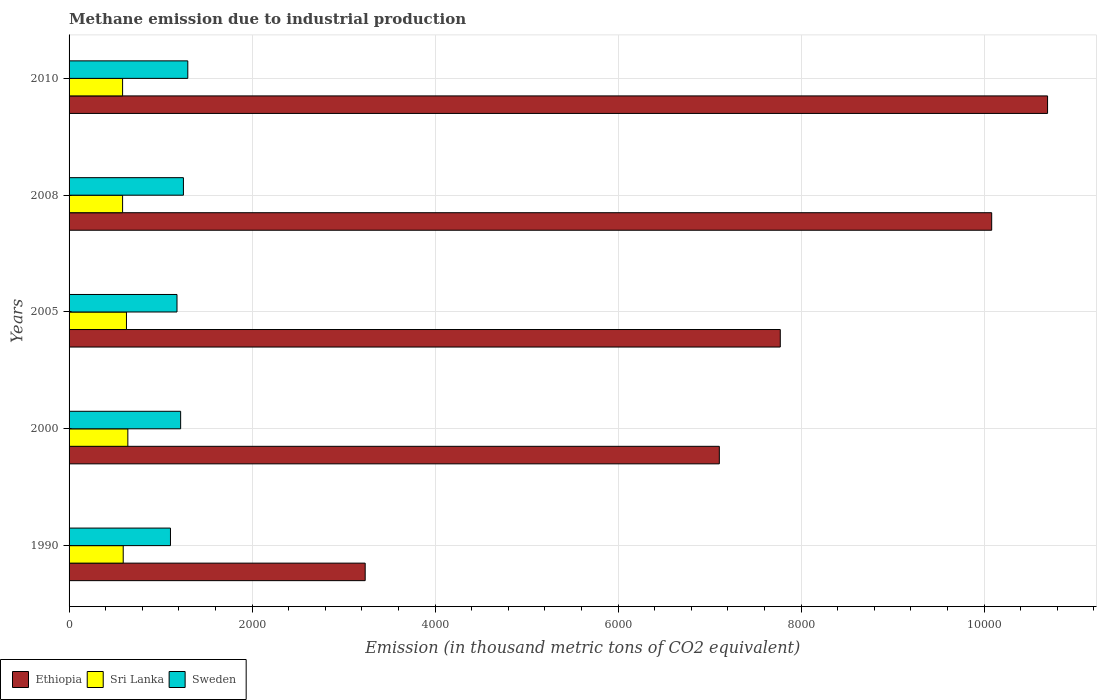How many groups of bars are there?
Offer a terse response. 5. In how many cases, is the number of bars for a given year not equal to the number of legend labels?
Keep it short and to the point. 0. What is the amount of methane emitted in Sri Lanka in 2008?
Offer a terse response. 584.9. Across all years, what is the maximum amount of methane emitted in Ethiopia?
Make the answer very short. 1.07e+04. Across all years, what is the minimum amount of methane emitted in Ethiopia?
Ensure brevity in your answer.  3236. In which year was the amount of methane emitted in Ethiopia minimum?
Provide a short and direct response. 1990. What is the total amount of methane emitted in Sweden in the graph?
Provide a succinct answer. 6054. What is the difference between the amount of methane emitted in Ethiopia in 1990 and that in 2000?
Your answer should be very brief. -3870. What is the difference between the amount of methane emitted in Sweden in 1990 and the amount of methane emitted in Ethiopia in 2008?
Make the answer very short. -8974.2. What is the average amount of methane emitted in Ethiopia per year?
Offer a terse response. 7777.88. In the year 2000, what is the difference between the amount of methane emitted in Ethiopia and amount of methane emitted in Sri Lanka?
Your response must be concise. 6463.8. What is the ratio of the amount of methane emitted in Sri Lanka in 2000 to that in 2005?
Your answer should be very brief. 1.02. Is the amount of methane emitted in Sweden in 2000 less than that in 2005?
Provide a short and direct response. No. Is the difference between the amount of methane emitted in Ethiopia in 2000 and 2010 greater than the difference between the amount of methane emitted in Sri Lanka in 2000 and 2010?
Give a very brief answer. No. What is the difference between the highest and the second highest amount of methane emitted in Sri Lanka?
Your response must be concise. 14.9. What is the difference between the highest and the lowest amount of methane emitted in Sweden?
Your answer should be compact. 189.4. In how many years, is the amount of methane emitted in Ethiopia greater than the average amount of methane emitted in Ethiopia taken over all years?
Provide a succinct answer. 2. Is the sum of the amount of methane emitted in Sweden in 2008 and 2010 greater than the maximum amount of methane emitted in Ethiopia across all years?
Give a very brief answer. No. What does the 3rd bar from the top in 2005 represents?
Offer a very short reply. Ethiopia. What does the 2nd bar from the bottom in 2008 represents?
Provide a short and direct response. Sri Lanka. Is it the case that in every year, the sum of the amount of methane emitted in Sri Lanka and amount of methane emitted in Ethiopia is greater than the amount of methane emitted in Sweden?
Make the answer very short. Yes. How many bars are there?
Your answer should be compact. 15. How many years are there in the graph?
Make the answer very short. 5. What is the difference between two consecutive major ticks on the X-axis?
Your answer should be very brief. 2000. Does the graph contain any zero values?
Provide a succinct answer. No. Does the graph contain grids?
Offer a terse response. Yes. Where does the legend appear in the graph?
Your answer should be very brief. Bottom left. What is the title of the graph?
Offer a terse response. Methane emission due to industrial production. Does "Burundi" appear as one of the legend labels in the graph?
Your answer should be compact. No. What is the label or title of the X-axis?
Your answer should be compact. Emission (in thousand metric tons of CO2 equivalent). What is the label or title of the Y-axis?
Your answer should be very brief. Years. What is the Emission (in thousand metric tons of CO2 equivalent) of Ethiopia in 1990?
Provide a succinct answer. 3236. What is the Emission (in thousand metric tons of CO2 equivalent) in Sri Lanka in 1990?
Make the answer very short. 591.8. What is the Emission (in thousand metric tons of CO2 equivalent) of Sweden in 1990?
Give a very brief answer. 1108.1. What is the Emission (in thousand metric tons of CO2 equivalent) in Ethiopia in 2000?
Your answer should be compact. 7106. What is the Emission (in thousand metric tons of CO2 equivalent) in Sri Lanka in 2000?
Your answer should be very brief. 642.2. What is the Emission (in thousand metric tons of CO2 equivalent) in Sweden in 2000?
Ensure brevity in your answer.  1219.3. What is the Emission (in thousand metric tons of CO2 equivalent) of Ethiopia in 2005?
Ensure brevity in your answer.  7772.1. What is the Emission (in thousand metric tons of CO2 equivalent) in Sri Lanka in 2005?
Provide a short and direct response. 627.3. What is the Emission (in thousand metric tons of CO2 equivalent) in Sweden in 2005?
Keep it short and to the point. 1179.4. What is the Emission (in thousand metric tons of CO2 equivalent) of Ethiopia in 2008?
Give a very brief answer. 1.01e+04. What is the Emission (in thousand metric tons of CO2 equivalent) in Sri Lanka in 2008?
Offer a terse response. 584.9. What is the Emission (in thousand metric tons of CO2 equivalent) in Sweden in 2008?
Offer a very short reply. 1249.7. What is the Emission (in thousand metric tons of CO2 equivalent) in Ethiopia in 2010?
Ensure brevity in your answer.  1.07e+04. What is the Emission (in thousand metric tons of CO2 equivalent) of Sri Lanka in 2010?
Your answer should be compact. 584.9. What is the Emission (in thousand metric tons of CO2 equivalent) in Sweden in 2010?
Provide a short and direct response. 1297.5. Across all years, what is the maximum Emission (in thousand metric tons of CO2 equivalent) of Ethiopia?
Keep it short and to the point. 1.07e+04. Across all years, what is the maximum Emission (in thousand metric tons of CO2 equivalent) in Sri Lanka?
Your response must be concise. 642.2. Across all years, what is the maximum Emission (in thousand metric tons of CO2 equivalent) in Sweden?
Make the answer very short. 1297.5. Across all years, what is the minimum Emission (in thousand metric tons of CO2 equivalent) in Ethiopia?
Your response must be concise. 3236. Across all years, what is the minimum Emission (in thousand metric tons of CO2 equivalent) of Sri Lanka?
Your answer should be compact. 584.9. Across all years, what is the minimum Emission (in thousand metric tons of CO2 equivalent) in Sweden?
Offer a terse response. 1108.1. What is the total Emission (in thousand metric tons of CO2 equivalent) of Ethiopia in the graph?
Your answer should be compact. 3.89e+04. What is the total Emission (in thousand metric tons of CO2 equivalent) of Sri Lanka in the graph?
Your response must be concise. 3031.1. What is the total Emission (in thousand metric tons of CO2 equivalent) in Sweden in the graph?
Provide a succinct answer. 6054. What is the difference between the Emission (in thousand metric tons of CO2 equivalent) in Ethiopia in 1990 and that in 2000?
Give a very brief answer. -3870. What is the difference between the Emission (in thousand metric tons of CO2 equivalent) in Sri Lanka in 1990 and that in 2000?
Keep it short and to the point. -50.4. What is the difference between the Emission (in thousand metric tons of CO2 equivalent) of Sweden in 1990 and that in 2000?
Offer a very short reply. -111.2. What is the difference between the Emission (in thousand metric tons of CO2 equivalent) in Ethiopia in 1990 and that in 2005?
Your answer should be very brief. -4536.1. What is the difference between the Emission (in thousand metric tons of CO2 equivalent) in Sri Lanka in 1990 and that in 2005?
Provide a short and direct response. -35.5. What is the difference between the Emission (in thousand metric tons of CO2 equivalent) in Sweden in 1990 and that in 2005?
Offer a terse response. -71.3. What is the difference between the Emission (in thousand metric tons of CO2 equivalent) in Ethiopia in 1990 and that in 2008?
Your answer should be very brief. -6846.3. What is the difference between the Emission (in thousand metric tons of CO2 equivalent) of Sweden in 1990 and that in 2008?
Your answer should be compact. -141.6. What is the difference between the Emission (in thousand metric tons of CO2 equivalent) of Ethiopia in 1990 and that in 2010?
Make the answer very short. -7457. What is the difference between the Emission (in thousand metric tons of CO2 equivalent) of Sri Lanka in 1990 and that in 2010?
Your response must be concise. 6.9. What is the difference between the Emission (in thousand metric tons of CO2 equivalent) of Sweden in 1990 and that in 2010?
Provide a short and direct response. -189.4. What is the difference between the Emission (in thousand metric tons of CO2 equivalent) of Ethiopia in 2000 and that in 2005?
Provide a short and direct response. -666.1. What is the difference between the Emission (in thousand metric tons of CO2 equivalent) in Sweden in 2000 and that in 2005?
Offer a very short reply. 39.9. What is the difference between the Emission (in thousand metric tons of CO2 equivalent) in Ethiopia in 2000 and that in 2008?
Offer a terse response. -2976.3. What is the difference between the Emission (in thousand metric tons of CO2 equivalent) of Sri Lanka in 2000 and that in 2008?
Offer a very short reply. 57.3. What is the difference between the Emission (in thousand metric tons of CO2 equivalent) in Sweden in 2000 and that in 2008?
Give a very brief answer. -30.4. What is the difference between the Emission (in thousand metric tons of CO2 equivalent) in Ethiopia in 2000 and that in 2010?
Provide a short and direct response. -3587. What is the difference between the Emission (in thousand metric tons of CO2 equivalent) of Sri Lanka in 2000 and that in 2010?
Offer a very short reply. 57.3. What is the difference between the Emission (in thousand metric tons of CO2 equivalent) of Sweden in 2000 and that in 2010?
Your answer should be compact. -78.2. What is the difference between the Emission (in thousand metric tons of CO2 equivalent) in Ethiopia in 2005 and that in 2008?
Keep it short and to the point. -2310.2. What is the difference between the Emission (in thousand metric tons of CO2 equivalent) of Sri Lanka in 2005 and that in 2008?
Ensure brevity in your answer.  42.4. What is the difference between the Emission (in thousand metric tons of CO2 equivalent) of Sweden in 2005 and that in 2008?
Make the answer very short. -70.3. What is the difference between the Emission (in thousand metric tons of CO2 equivalent) of Ethiopia in 2005 and that in 2010?
Provide a succinct answer. -2920.9. What is the difference between the Emission (in thousand metric tons of CO2 equivalent) of Sri Lanka in 2005 and that in 2010?
Your answer should be very brief. 42.4. What is the difference between the Emission (in thousand metric tons of CO2 equivalent) in Sweden in 2005 and that in 2010?
Provide a succinct answer. -118.1. What is the difference between the Emission (in thousand metric tons of CO2 equivalent) of Ethiopia in 2008 and that in 2010?
Make the answer very short. -610.7. What is the difference between the Emission (in thousand metric tons of CO2 equivalent) of Sri Lanka in 2008 and that in 2010?
Offer a terse response. 0. What is the difference between the Emission (in thousand metric tons of CO2 equivalent) in Sweden in 2008 and that in 2010?
Make the answer very short. -47.8. What is the difference between the Emission (in thousand metric tons of CO2 equivalent) of Ethiopia in 1990 and the Emission (in thousand metric tons of CO2 equivalent) of Sri Lanka in 2000?
Make the answer very short. 2593.8. What is the difference between the Emission (in thousand metric tons of CO2 equivalent) in Ethiopia in 1990 and the Emission (in thousand metric tons of CO2 equivalent) in Sweden in 2000?
Your response must be concise. 2016.7. What is the difference between the Emission (in thousand metric tons of CO2 equivalent) in Sri Lanka in 1990 and the Emission (in thousand metric tons of CO2 equivalent) in Sweden in 2000?
Your answer should be very brief. -627.5. What is the difference between the Emission (in thousand metric tons of CO2 equivalent) of Ethiopia in 1990 and the Emission (in thousand metric tons of CO2 equivalent) of Sri Lanka in 2005?
Provide a succinct answer. 2608.7. What is the difference between the Emission (in thousand metric tons of CO2 equivalent) of Ethiopia in 1990 and the Emission (in thousand metric tons of CO2 equivalent) of Sweden in 2005?
Give a very brief answer. 2056.6. What is the difference between the Emission (in thousand metric tons of CO2 equivalent) of Sri Lanka in 1990 and the Emission (in thousand metric tons of CO2 equivalent) of Sweden in 2005?
Provide a short and direct response. -587.6. What is the difference between the Emission (in thousand metric tons of CO2 equivalent) of Ethiopia in 1990 and the Emission (in thousand metric tons of CO2 equivalent) of Sri Lanka in 2008?
Your answer should be very brief. 2651.1. What is the difference between the Emission (in thousand metric tons of CO2 equivalent) in Ethiopia in 1990 and the Emission (in thousand metric tons of CO2 equivalent) in Sweden in 2008?
Provide a succinct answer. 1986.3. What is the difference between the Emission (in thousand metric tons of CO2 equivalent) of Sri Lanka in 1990 and the Emission (in thousand metric tons of CO2 equivalent) of Sweden in 2008?
Your response must be concise. -657.9. What is the difference between the Emission (in thousand metric tons of CO2 equivalent) of Ethiopia in 1990 and the Emission (in thousand metric tons of CO2 equivalent) of Sri Lanka in 2010?
Make the answer very short. 2651.1. What is the difference between the Emission (in thousand metric tons of CO2 equivalent) of Ethiopia in 1990 and the Emission (in thousand metric tons of CO2 equivalent) of Sweden in 2010?
Provide a succinct answer. 1938.5. What is the difference between the Emission (in thousand metric tons of CO2 equivalent) of Sri Lanka in 1990 and the Emission (in thousand metric tons of CO2 equivalent) of Sweden in 2010?
Give a very brief answer. -705.7. What is the difference between the Emission (in thousand metric tons of CO2 equivalent) of Ethiopia in 2000 and the Emission (in thousand metric tons of CO2 equivalent) of Sri Lanka in 2005?
Your answer should be very brief. 6478.7. What is the difference between the Emission (in thousand metric tons of CO2 equivalent) in Ethiopia in 2000 and the Emission (in thousand metric tons of CO2 equivalent) in Sweden in 2005?
Keep it short and to the point. 5926.6. What is the difference between the Emission (in thousand metric tons of CO2 equivalent) of Sri Lanka in 2000 and the Emission (in thousand metric tons of CO2 equivalent) of Sweden in 2005?
Ensure brevity in your answer.  -537.2. What is the difference between the Emission (in thousand metric tons of CO2 equivalent) of Ethiopia in 2000 and the Emission (in thousand metric tons of CO2 equivalent) of Sri Lanka in 2008?
Give a very brief answer. 6521.1. What is the difference between the Emission (in thousand metric tons of CO2 equivalent) of Ethiopia in 2000 and the Emission (in thousand metric tons of CO2 equivalent) of Sweden in 2008?
Your response must be concise. 5856.3. What is the difference between the Emission (in thousand metric tons of CO2 equivalent) in Sri Lanka in 2000 and the Emission (in thousand metric tons of CO2 equivalent) in Sweden in 2008?
Keep it short and to the point. -607.5. What is the difference between the Emission (in thousand metric tons of CO2 equivalent) in Ethiopia in 2000 and the Emission (in thousand metric tons of CO2 equivalent) in Sri Lanka in 2010?
Keep it short and to the point. 6521.1. What is the difference between the Emission (in thousand metric tons of CO2 equivalent) in Ethiopia in 2000 and the Emission (in thousand metric tons of CO2 equivalent) in Sweden in 2010?
Keep it short and to the point. 5808.5. What is the difference between the Emission (in thousand metric tons of CO2 equivalent) of Sri Lanka in 2000 and the Emission (in thousand metric tons of CO2 equivalent) of Sweden in 2010?
Offer a very short reply. -655.3. What is the difference between the Emission (in thousand metric tons of CO2 equivalent) in Ethiopia in 2005 and the Emission (in thousand metric tons of CO2 equivalent) in Sri Lanka in 2008?
Ensure brevity in your answer.  7187.2. What is the difference between the Emission (in thousand metric tons of CO2 equivalent) of Ethiopia in 2005 and the Emission (in thousand metric tons of CO2 equivalent) of Sweden in 2008?
Your response must be concise. 6522.4. What is the difference between the Emission (in thousand metric tons of CO2 equivalent) in Sri Lanka in 2005 and the Emission (in thousand metric tons of CO2 equivalent) in Sweden in 2008?
Keep it short and to the point. -622.4. What is the difference between the Emission (in thousand metric tons of CO2 equivalent) of Ethiopia in 2005 and the Emission (in thousand metric tons of CO2 equivalent) of Sri Lanka in 2010?
Your answer should be very brief. 7187.2. What is the difference between the Emission (in thousand metric tons of CO2 equivalent) of Ethiopia in 2005 and the Emission (in thousand metric tons of CO2 equivalent) of Sweden in 2010?
Provide a short and direct response. 6474.6. What is the difference between the Emission (in thousand metric tons of CO2 equivalent) in Sri Lanka in 2005 and the Emission (in thousand metric tons of CO2 equivalent) in Sweden in 2010?
Your response must be concise. -670.2. What is the difference between the Emission (in thousand metric tons of CO2 equivalent) of Ethiopia in 2008 and the Emission (in thousand metric tons of CO2 equivalent) of Sri Lanka in 2010?
Offer a terse response. 9497.4. What is the difference between the Emission (in thousand metric tons of CO2 equivalent) of Ethiopia in 2008 and the Emission (in thousand metric tons of CO2 equivalent) of Sweden in 2010?
Your response must be concise. 8784.8. What is the difference between the Emission (in thousand metric tons of CO2 equivalent) of Sri Lanka in 2008 and the Emission (in thousand metric tons of CO2 equivalent) of Sweden in 2010?
Your answer should be very brief. -712.6. What is the average Emission (in thousand metric tons of CO2 equivalent) of Ethiopia per year?
Provide a short and direct response. 7777.88. What is the average Emission (in thousand metric tons of CO2 equivalent) in Sri Lanka per year?
Provide a succinct answer. 606.22. What is the average Emission (in thousand metric tons of CO2 equivalent) in Sweden per year?
Provide a succinct answer. 1210.8. In the year 1990, what is the difference between the Emission (in thousand metric tons of CO2 equivalent) in Ethiopia and Emission (in thousand metric tons of CO2 equivalent) in Sri Lanka?
Offer a terse response. 2644.2. In the year 1990, what is the difference between the Emission (in thousand metric tons of CO2 equivalent) in Ethiopia and Emission (in thousand metric tons of CO2 equivalent) in Sweden?
Your answer should be compact. 2127.9. In the year 1990, what is the difference between the Emission (in thousand metric tons of CO2 equivalent) in Sri Lanka and Emission (in thousand metric tons of CO2 equivalent) in Sweden?
Keep it short and to the point. -516.3. In the year 2000, what is the difference between the Emission (in thousand metric tons of CO2 equivalent) in Ethiopia and Emission (in thousand metric tons of CO2 equivalent) in Sri Lanka?
Keep it short and to the point. 6463.8. In the year 2000, what is the difference between the Emission (in thousand metric tons of CO2 equivalent) of Ethiopia and Emission (in thousand metric tons of CO2 equivalent) of Sweden?
Keep it short and to the point. 5886.7. In the year 2000, what is the difference between the Emission (in thousand metric tons of CO2 equivalent) in Sri Lanka and Emission (in thousand metric tons of CO2 equivalent) in Sweden?
Your response must be concise. -577.1. In the year 2005, what is the difference between the Emission (in thousand metric tons of CO2 equivalent) of Ethiopia and Emission (in thousand metric tons of CO2 equivalent) of Sri Lanka?
Offer a terse response. 7144.8. In the year 2005, what is the difference between the Emission (in thousand metric tons of CO2 equivalent) of Ethiopia and Emission (in thousand metric tons of CO2 equivalent) of Sweden?
Give a very brief answer. 6592.7. In the year 2005, what is the difference between the Emission (in thousand metric tons of CO2 equivalent) of Sri Lanka and Emission (in thousand metric tons of CO2 equivalent) of Sweden?
Provide a succinct answer. -552.1. In the year 2008, what is the difference between the Emission (in thousand metric tons of CO2 equivalent) of Ethiopia and Emission (in thousand metric tons of CO2 equivalent) of Sri Lanka?
Your answer should be compact. 9497.4. In the year 2008, what is the difference between the Emission (in thousand metric tons of CO2 equivalent) in Ethiopia and Emission (in thousand metric tons of CO2 equivalent) in Sweden?
Give a very brief answer. 8832.6. In the year 2008, what is the difference between the Emission (in thousand metric tons of CO2 equivalent) in Sri Lanka and Emission (in thousand metric tons of CO2 equivalent) in Sweden?
Offer a very short reply. -664.8. In the year 2010, what is the difference between the Emission (in thousand metric tons of CO2 equivalent) of Ethiopia and Emission (in thousand metric tons of CO2 equivalent) of Sri Lanka?
Offer a very short reply. 1.01e+04. In the year 2010, what is the difference between the Emission (in thousand metric tons of CO2 equivalent) in Ethiopia and Emission (in thousand metric tons of CO2 equivalent) in Sweden?
Offer a very short reply. 9395.5. In the year 2010, what is the difference between the Emission (in thousand metric tons of CO2 equivalent) of Sri Lanka and Emission (in thousand metric tons of CO2 equivalent) of Sweden?
Provide a succinct answer. -712.6. What is the ratio of the Emission (in thousand metric tons of CO2 equivalent) in Ethiopia in 1990 to that in 2000?
Ensure brevity in your answer.  0.46. What is the ratio of the Emission (in thousand metric tons of CO2 equivalent) of Sri Lanka in 1990 to that in 2000?
Keep it short and to the point. 0.92. What is the ratio of the Emission (in thousand metric tons of CO2 equivalent) of Sweden in 1990 to that in 2000?
Ensure brevity in your answer.  0.91. What is the ratio of the Emission (in thousand metric tons of CO2 equivalent) of Ethiopia in 1990 to that in 2005?
Your answer should be compact. 0.42. What is the ratio of the Emission (in thousand metric tons of CO2 equivalent) of Sri Lanka in 1990 to that in 2005?
Your answer should be compact. 0.94. What is the ratio of the Emission (in thousand metric tons of CO2 equivalent) in Sweden in 1990 to that in 2005?
Offer a very short reply. 0.94. What is the ratio of the Emission (in thousand metric tons of CO2 equivalent) in Ethiopia in 1990 to that in 2008?
Ensure brevity in your answer.  0.32. What is the ratio of the Emission (in thousand metric tons of CO2 equivalent) of Sri Lanka in 1990 to that in 2008?
Make the answer very short. 1.01. What is the ratio of the Emission (in thousand metric tons of CO2 equivalent) in Sweden in 1990 to that in 2008?
Give a very brief answer. 0.89. What is the ratio of the Emission (in thousand metric tons of CO2 equivalent) in Ethiopia in 1990 to that in 2010?
Provide a short and direct response. 0.3. What is the ratio of the Emission (in thousand metric tons of CO2 equivalent) of Sri Lanka in 1990 to that in 2010?
Your answer should be compact. 1.01. What is the ratio of the Emission (in thousand metric tons of CO2 equivalent) of Sweden in 1990 to that in 2010?
Your answer should be compact. 0.85. What is the ratio of the Emission (in thousand metric tons of CO2 equivalent) in Ethiopia in 2000 to that in 2005?
Give a very brief answer. 0.91. What is the ratio of the Emission (in thousand metric tons of CO2 equivalent) in Sri Lanka in 2000 to that in 2005?
Give a very brief answer. 1.02. What is the ratio of the Emission (in thousand metric tons of CO2 equivalent) of Sweden in 2000 to that in 2005?
Offer a terse response. 1.03. What is the ratio of the Emission (in thousand metric tons of CO2 equivalent) in Ethiopia in 2000 to that in 2008?
Make the answer very short. 0.7. What is the ratio of the Emission (in thousand metric tons of CO2 equivalent) in Sri Lanka in 2000 to that in 2008?
Provide a short and direct response. 1.1. What is the ratio of the Emission (in thousand metric tons of CO2 equivalent) of Sweden in 2000 to that in 2008?
Provide a succinct answer. 0.98. What is the ratio of the Emission (in thousand metric tons of CO2 equivalent) of Ethiopia in 2000 to that in 2010?
Ensure brevity in your answer.  0.66. What is the ratio of the Emission (in thousand metric tons of CO2 equivalent) of Sri Lanka in 2000 to that in 2010?
Make the answer very short. 1.1. What is the ratio of the Emission (in thousand metric tons of CO2 equivalent) in Sweden in 2000 to that in 2010?
Keep it short and to the point. 0.94. What is the ratio of the Emission (in thousand metric tons of CO2 equivalent) in Ethiopia in 2005 to that in 2008?
Your response must be concise. 0.77. What is the ratio of the Emission (in thousand metric tons of CO2 equivalent) in Sri Lanka in 2005 to that in 2008?
Your answer should be compact. 1.07. What is the ratio of the Emission (in thousand metric tons of CO2 equivalent) in Sweden in 2005 to that in 2008?
Your response must be concise. 0.94. What is the ratio of the Emission (in thousand metric tons of CO2 equivalent) of Ethiopia in 2005 to that in 2010?
Provide a short and direct response. 0.73. What is the ratio of the Emission (in thousand metric tons of CO2 equivalent) in Sri Lanka in 2005 to that in 2010?
Your answer should be very brief. 1.07. What is the ratio of the Emission (in thousand metric tons of CO2 equivalent) of Sweden in 2005 to that in 2010?
Make the answer very short. 0.91. What is the ratio of the Emission (in thousand metric tons of CO2 equivalent) of Ethiopia in 2008 to that in 2010?
Give a very brief answer. 0.94. What is the ratio of the Emission (in thousand metric tons of CO2 equivalent) in Sweden in 2008 to that in 2010?
Your answer should be very brief. 0.96. What is the difference between the highest and the second highest Emission (in thousand metric tons of CO2 equivalent) in Ethiopia?
Give a very brief answer. 610.7. What is the difference between the highest and the second highest Emission (in thousand metric tons of CO2 equivalent) in Sweden?
Offer a very short reply. 47.8. What is the difference between the highest and the lowest Emission (in thousand metric tons of CO2 equivalent) of Ethiopia?
Ensure brevity in your answer.  7457. What is the difference between the highest and the lowest Emission (in thousand metric tons of CO2 equivalent) in Sri Lanka?
Offer a very short reply. 57.3. What is the difference between the highest and the lowest Emission (in thousand metric tons of CO2 equivalent) in Sweden?
Ensure brevity in your answer.  189.4. 